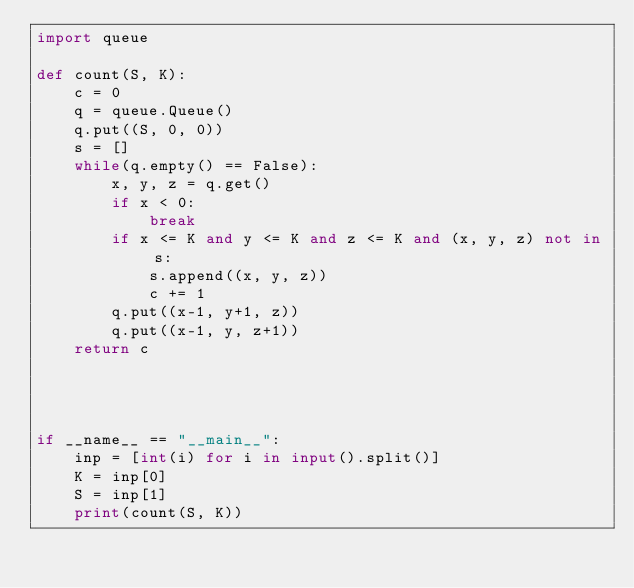<code> <loc_0><loc_0><loc_500><loc_500><_Python_>import queue

def count(S, K):
    c = 0
    q = queue.Queue()
    q.put((S, 0, 0))
    s = []
    while(q.empty() == False):
        x, y, z = q.get()
        if x < 0:
            break
        if x <= K and y <= K and z <= K and (x, y, z) not in s:
            s.append((x, y, z))
            c += 1
        q.put((x-1, y+1, z))
        q.put((x-1, y, z+1))
    return c




if __name__ == "__main__":
    inp = [int(i) for i in input().split()]
    K = inp[0]
    S = inp[1]
    print(count(S, K))</code> 